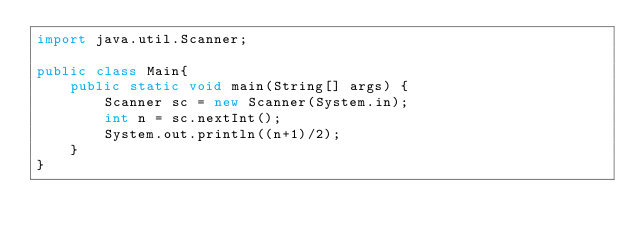<code> <loc_0><loc_0><loc_500><loc_500><_Java_>import java.util.Scanner;

public class Main{
	public static void main(String[] args) {
		Scanner sc = new Scanner(System.in);
		int n = sc.nextInt();
		System.out.println((n+1)/2);
	}
}</code> 